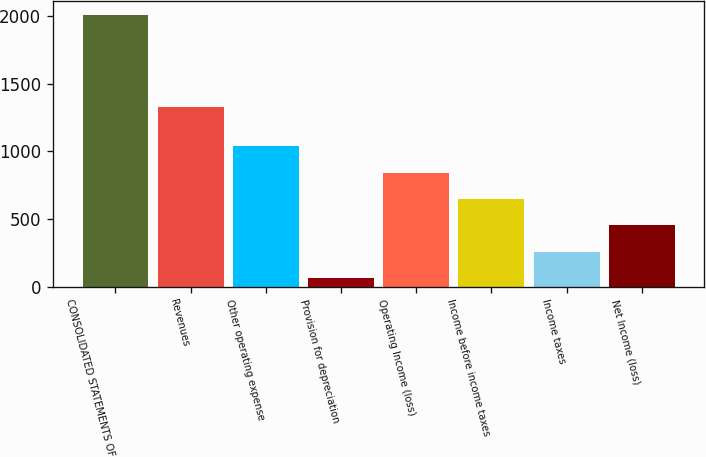Convert chart. <chart><loc_0><loc_0><loc_500><loc_500><bar_chart><fcel>CONSOLIDATED STATEMENTS OF<fcel>Revenues<fcel>Other operating expense<fcel>Provision for depreciation<fcel>Operating Income (loss)<fcel>Income before income taxes<fcel>Income taxes<fcel>Net Income (loss)<nl><fcel>2010<fcel>1326<fcel>1036.5<fcel>63<fcel>841.8<fcel>647.1<fcel>257.7<fcel>452.4<nl></chart> 